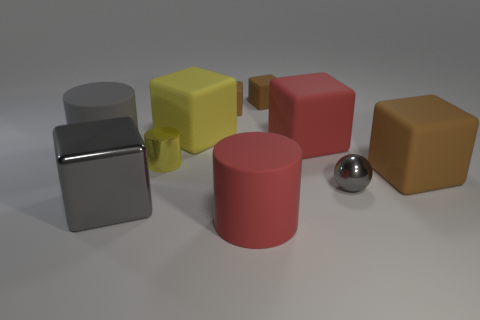There is a metal cube that is in front of the large brown rubber block; how big is it?
Your response must be concise. Large. The yellow block has what size?
Keep it short and to the point. Large. What number of blocks are brown things or red rubber objects?
Keep it short and to the point. 4. There is a yellow thing that is the same material as the large red cube; what is its size?
Provide a succinct answer. Large. How many other big cylinders are the same color as the metal cylinder?
Your response must be concise. 0. Are there any gray metal balls to the left of the tiny ball?
Your answer should be compact. No. There is a large yellow thing; is its shape the same as the big red rubber thing behind the gray block?
Ensure brevity in your answer.  Yes. What number of objects are blocks to the right of the large gray block or green blocks?
Give a very brief answer. 5. How many gray metal things are both left of the red rubber cylinder and right of the yellow shiny object?
Give a very brief answer. 0. What number of objects are either big matte things that are left of the big red matte cylinder or red objects that are behind the tiny gray metallic object?
Offer a terse response. 3. 